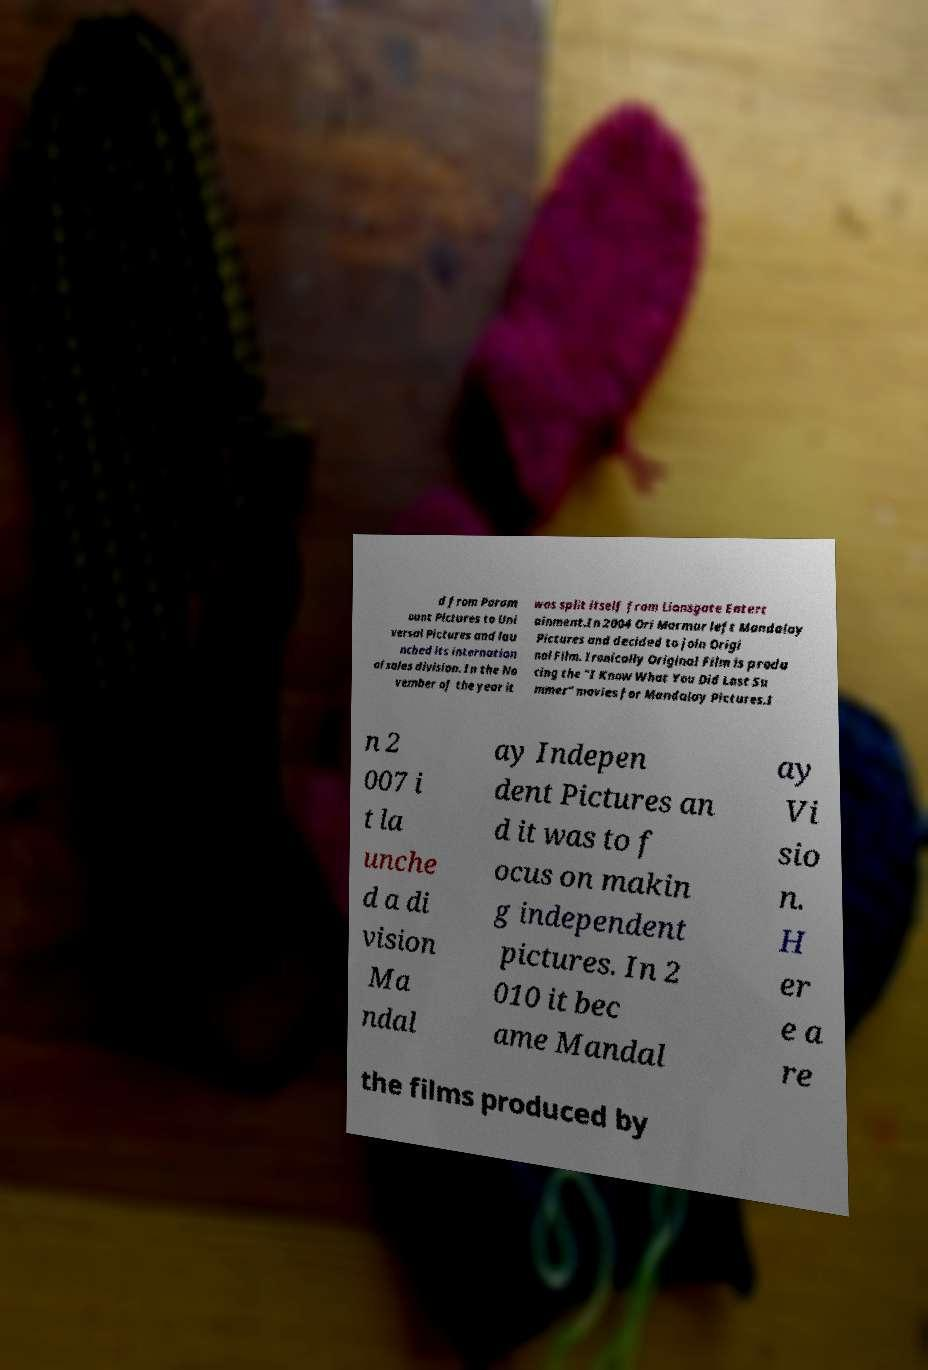For documentation purposes, I need the text within this image transcribed. Could you provide that? d from Param ount Pictures to Uni versal Pictures and lau nched its internation al sales division. In the No vember of the year it was split itself from Lionsgate Entert ainment.In 2004 Ori Marmur left Mandalay Pictures and decided to join Origi nal Film. Ironically Original Film is produ cing the "I Know What You Did Last Su mmer" movies for Mandalay Pictures.I n 2 007 i t la unche d a di vision Ma ndal ay Indepen dent Pictures an d it was to f ocus on makin g independent pictures. In 2 010 it bec ame Mandal ay Vi sio n. H er e a re the films produced by 